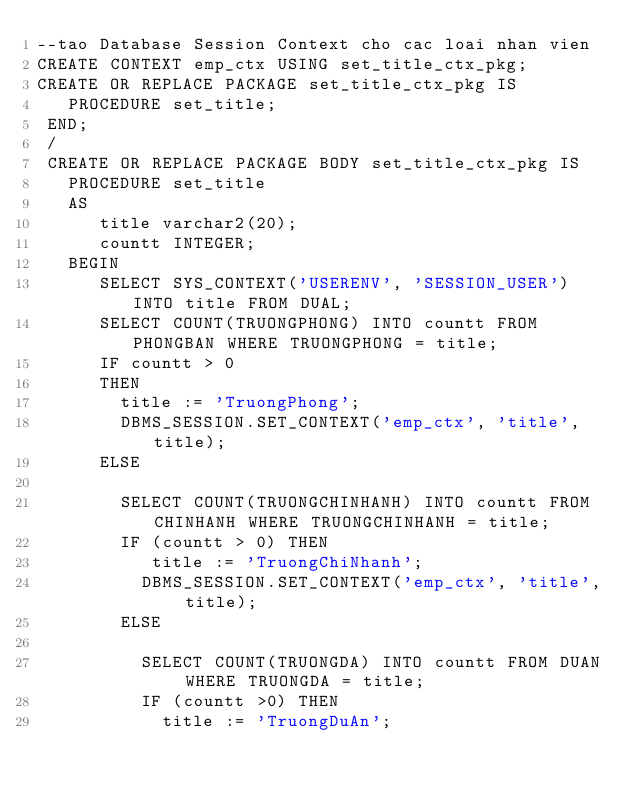Convert code to text. <code><loc_0><loc_0><loc_500><loc_500><_SQL_>--tao Database Session Context cho cac loai nhan vien
CREATE CONTEXT emp_ctx USING set_title_ctx_pkg;
CREATE OR REPLACE PACKAGE set_title_ctx_pkg IS 
   PROCEDURE set_title; 
 END; 
 /
 CREATE OR REPLACE PACKAGE BODY set_title_ctx_pkg IS
   PROCEDURE set_title
   AS 
      title varchar2(20);
      countt INTEGER;
   BEGIN
      SELECT SYS_CONTEXT('USERENV', 'SESSION_USER') INTO title FROM DUAL;
      SELECT COUNT(TRUONGPHONG) INTO countt FROM PHONGBAN WHERE TRUONGPHONG = title;
      IF countt > 0
      THEN
        title := 'TruongPhong';
        DBMS_SESSION.SET_CONTEXT('emp_ctx', 'title', title);
      ELSE
      
        SELECT COUNT(TRUONGCHINHANH) INTO countt FROM CHINHANH WHERE TRUONGCHINHANH = title;
        IF (countt > 0) THEN
           title := 'TruongChiNhanh';
          DBMS_SESSION.SET_CONTEXT('emp_ctx', 'title', title);
        ELSE
          
          SELECT COUNT(TRUONGDA) INTO countt FROM DUAN WHERE TRUONGDA = title;
          IF (countt >0) THEN
            title := 'TruongDuAn';</code> 